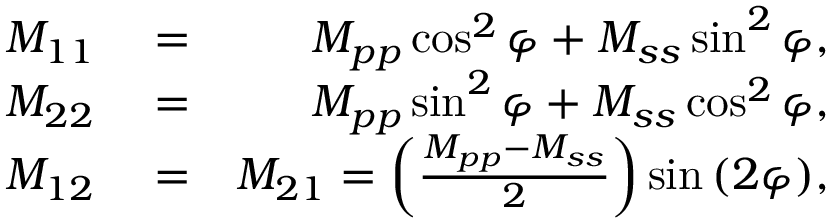<formula> <loc_0><loc_0><loc_500><loc_500>\begin{array} { r l r } { M _ { 1 1 } } & = } & { M _ { p p } \cos ^ { 2 } \varphi + M _ { s s } \sin ^ { 2 } \varphi , } \\ { M _ { 2 2 } } & = } & { M _ { p p } \sin ^ { 2 } \varphi + M _ { s s } \cos ^ { 2 } \varphi , } \\ { M _ { 1 2 } } & = } & { M _ { 2 1 } = \left ( \frac { M _ { p p } - M _ { s s } } { 2 } \right ) \sin { ( 2 \varphi ) } , } \end{array}</formula> 